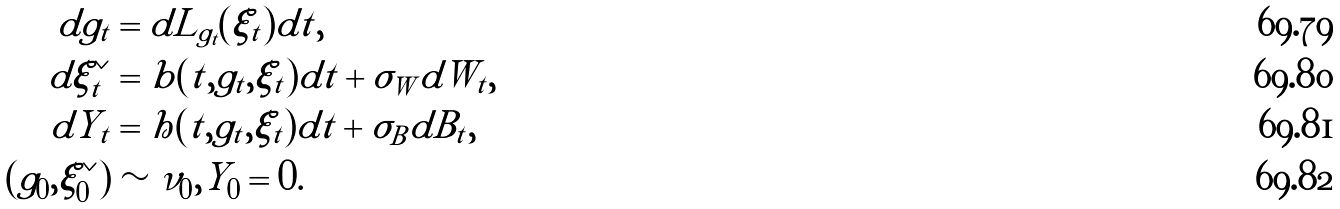<formula> <loc_0><loc_0><loc_500><loc_500>d g _ { t } & = d L _ { g _ { t } } ( \xi _ { t } ) d t , \\ d \xi _ { t } ^ { \vee } & = b ( t , g _ { t } , \xi _ { t } ) d t + \sigma _ { W } d W _ { t } , \\ d Y _ { t } & = h ( t , g _ { t } , \xi _ { t } ) d t + \sigma _ { B } d B _ { t } , \\ ( g _ { 0 } , \xi _ { 0 } ^ { \vee } ) & \sim \nu _ { 0 } , Y _ { 0 } = 0 .</formula> 